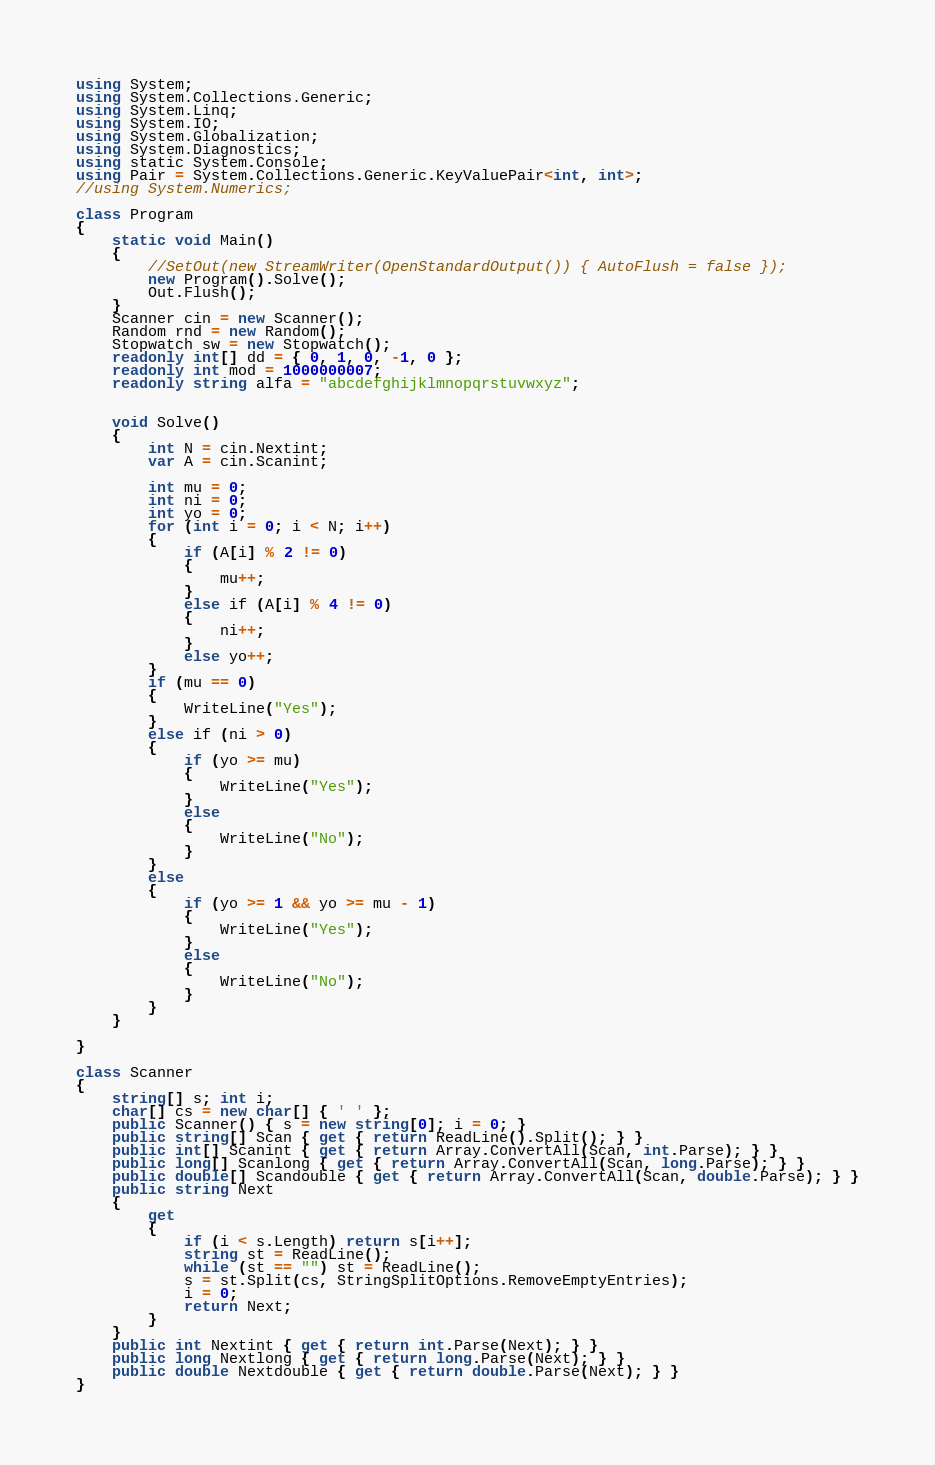<code> <loc_0><loc_0><loc_500><loc_500><_C#_>using System;
using System.Collections.Generic;
using System.Linq;
using System.IO;
using System.Globalization;
using System.Diagnostics;
using static System.Console;
using Pair = System.Collections.Generic.KeyValuePair<int, int>;
//using System.Numerics;

class Program
{
    static void Main()
    {
        //SetOut(new StreamWriter(OpenStandardOutput()) { AutoFlush = false });
        new Program().Solve();
        Out.Flush();
    }
    Scanner cin = new Scanner();
    Random rnd = new Random();
    Stopwatch sw = new Stopwatch();
    readonly int[] dd = { 0, 1, 0, -1, 0 };
    readonly int mod = 1000000007;
    readonly string alfa = "abcdefghijklmnopqrstuvwxyz";


    void Solve()
    {
        int N = cin.Nextint;
        var A = cin.Scanint;

        int mu = 0;
        int ni = 0;
        int yo = 0;
        for (int i = 0; i < N; i++)
        {
            if (A[i] % 2 != 0)
            {
                mu++;
            }
            else if (A[i] % 4 != 0)
            {
                ni++;
            }
            else yo++;
        }
        if (mu == 0)
        {
            WriteLine("Yes");
        }
        else if (ni > 0)
        {
            if (yo >= mu)
            {
                WriteLine("Yes");
            }
            else
            {
                WriteLine("No");
            }
        }
        else
        {
            if (yo >= 1 && yo >= mu - 1)
            {
                WriteLine("Yes");
            }
            else
            {
                WriteLine("No");
            }
        }
    }

}

class Scanner
{
    string[] s; int i;
    char[] cs = new char[] { ' ' };
    public Scanner() { s = new string[0]; i = 0; }
    public string[] Scan { get { return ReadLine().Split(); } }
    public int[] Scanint { get { return Array.ConvertAll(Scan, int.Parse); } }
    public long[] Scanlong { get { return Array.ConvertAll(Scan, long.Parse); } }
    public double[] Scandouble { get { return Array.ConvertAll(Scan, double.Parse); } }
    public string Next
    {
        get
        {
            if (i < s.Length) return s[i++];
            string st = ReadLine();
            while (st == "") st = ReadLine();
            s = st.Split(cs, StringSplitOptions.RemoveEmptyEntries);
            i = 0;
            return Next;
        }
    }
    public int Nextint { get { return int.Parse(Next); } }
    public long Nextlong { get { return long.Parse(Next); } }
    public double Nextdouble { get { return double.Parse(Next); } }
}</code> 